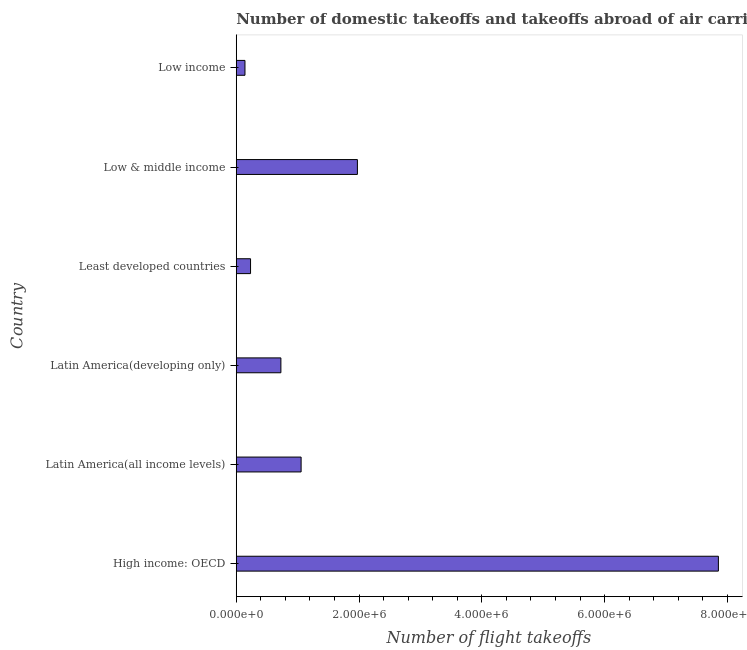Does the graph contain grids?
Provide a short and direct response. No. What is the title of the graph?
Your answer should be very brief. Number of domestic takeoffs and takeoffs abroad of air carriers registered in countries. What is the label or title of the X-axis?
Provide a succinct answer. Number of flight takeoffs. What is the label or title of the Y-axis?
Your answer should be very brief. Country. What is the number of flight takeoffs in Latin America(developing only)?
Your answer should be very brief. 7.27e+05. Across all countries, what is the maximum number of flight takeoffs?
Give a very brief answer. 7.85e+06. Across all countries, what is the minimum number of flight takeoffs?
Provide a short and direct response. 1.42e+05. In which country was the number of flight takeoffs maximum?
Your response must be concise. High income: OECD. In which country was the number of flight takeoffs minimum?
Your response must be concise. Low income. What is the sum of the number of flight takeoffs?
Offer a very short reply. 1.20e+07. What is the difference between the number of flight takeoffs in High income: OECD and Low & middle income?
Provide a succinct answer. 5.88e+06. What is the average number of flight takeoffs per country?
Keep it short and to the point. 2.00e+06. What is the median number of flight takeoffs?
Keep it short and to the point. 8.92e+05. What is the ratio of the number of flight takeoffs in Latin America(developing only) to that in Least developed countries?
Provide a succinct answer. 3.12. What is the difference between the highest and the second highest number of flight takeoffs?
Give a very brief answer. 5.88e+06. What is the difference between the highest and the lowest number of flight takeoffs?
Your response must be concise. 7.71e+06. In how many countries, is the number of flight takeoffs greater than the average number of flight takeoffs taken over all countries?
Offer a very short reply. 1. What is the difference between two consecutive major ticks on the X-axis?
Your response must be concise. 2.00e+06. Are the values on the major ticks of X-axis written in scientific E-notation?
Keep it short and to the point. Yes. What is the Number of flight takeoffs of High income: OECD?
Your response must be concise. 7.85e+06. What is the Number of flight takeoffs in Latin America(all income levels)?
Ensure brevity in your answer.  1.06e+06. What is the Number of flight takeoffs in Latin America(developing only)?
Give a very brief answer. 7.27e+05. What is the Number of flight takeoffs in Least developed countries?
Make the answer very short. 2.33e+05. What is the Number of flight takeoffs of Low & middle income?
Your answer should be compact. 1.97e+06. What is the Number of flight takeoffs in Low income?
Make the answer very short. 1.42e+05. What is the difference between the Number of flight takeoffs in High income: OECD and Latin America(all income levels)?
Provide a short and direct response. 6.80e+06. What is the difference between the Number of flight takeoffs in High income: OECD and Latin America(developing only)?
Offer a very short reply. 7.13e+06. What is the difference between the Number of flight takeoffs in High income: OECD and Least developed countries?
Your answer should be compact. 7.62e+06. What is the difference between the Number of flight takeoffs in High income: OECD and Low & middle income?
Provide a succinct answer. 5.88e+06. What is the difference between the Number of flight takeoffs in High income: OECD and Low income?
Your answer should be very brief. 7.71e+06. What is the difference between the Number of flight takeoffs in Latin America(all income levels) and Latin America(developing only)?
Your answer should be compact. 3.29e+05. What is the difference between the Number of flight takeoffs in Latin America(all income levels) and Least developed countries?
Keep it short and to the point. 8.24e+05. What is the difference between the Number of flight takeoffs in Latin America(all income levels) and Low & middle income?
Ensure brevity in your answer.  -9.17e+05. What is the difference between the Number of flight takeoffs in Latin America(all income levels) and Low income?
Provide a succinct answer. 9.15e+05. What is the difference between the Number of flight takeoffs in Latin America(developing only) and Least developed countries?
Ensure brevity in your answer.  4.94e+05. What is the difference between the Number of flight takeoffs in Latin America(developing only) and Low & middle income?
Ensure brevity in your answer.  -1.25e+06. What is the difference between the Number of flight takeoffs in Latin America(developing only) and Low income?
Ensure brevity in your answer.  5.85e+05. What is the difference between the Number of flight takeoffs in Least developed countries and Low & middle income?
Provide a succinct answer. -1.74e+06. What is the difference between the Number of flight takeoffs in Least developed countries and Low income?
Your answer should be very brief. 9.09e+04. What is the difference between the Number of flight takeoffs in Low & middle income and Low income?
Provide a short and direct response. 1.83e+06. What is the ratio of the Number of flight takeoffs in High income: OECD to that in Latin America(all income levels)?
Your response must be concise. 7.43. What is the ratio of the Number of flight takeoffs in High income: OECD to that in Least developed countries?
Provide a succinct answer. 33.74. What is the ratio of the Number of flight takeoffs in High income: OECD to that in Low & middle income?
Give a very brief answer. 3.98. What is the ratio of the Number of flight takeoffs in High income: OECD to that in Low income?
Your answer should be very brief. 55.35. What is the ratio of the Number of flight takeoffs in Latin America(all income levels) to that in Latin America(developing only)?
Your answer should be very brief. 1.45. What is the ratio of the Number of flight takeoffs in Latin America(all income levels) to that in Least developed countries?
Provide a short and direct response. 4.54. What is the ratio of the Number of flight takeoffs in Latin America(all income levels) to that in Low & middle income?
Offer a very short reply. 0.54. What is the ratio of the Number of flight takeoffs in Latin America(all income levels) to that in Low income?
Give a very brief answer. 7.45. What is the ratio of the Number of flight takeoffs in Latin America(developing only) to that in Least developed countries?
Make the answer very short. 3.12. What is the ratio of the Number of flight takeoffs in Latin America(developing only) to that in Low & middle income?
Provide a succinct answer. 0.37. What is the ratio of the Number of flight takeoffs in Latin America(developing only) to that in Low income?
Your answer should be compact. 5.12. What is the ratio of the Number of flight takeoffs in Least developed countries to that in Low & middle income?
Make the answer very short. 0.12. What is the ratio of the Number of flight takeoffs in Least developed countries to that in Low income?
Provide a succinct answer. 1.64. What is the ratio of the Number of flight takeoffs in Low & middle income to that in Low income?
Your answer should be very brief. 13.91. 